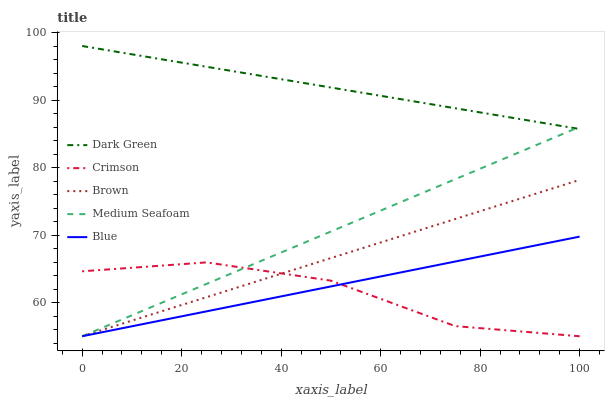Does Crimson have the minimum area under the curve?
Answer yes or no. Yes. Does Dark Green have the maximum area under the curve?
Answer yes or no. Yes. Does Brown have the minimum area under the curve?
Answer yes or no. No. Does Brown have the maximum area under the curve?
Answer yes or no. No. Is Brown the smoothest?
Answer yes or no. Yes. Is Crimson the roughest?
Answer yes or no. Yes. Is Blue the smoothest?
Answer yes or no. No. Is Blue the roughest?
Answer yes or no. No. Does Crimson have the lowest value?
Answer yes or no. Yes. Does Dark Green have the lowest value?
Answer yes or no. No. Does Dark Green have the highest value?
Answer yes or no. Yes. Does Brown have the highest value?
Answer yes or no. No. Is Crimson less than Dark Green?
Answer yes or no. Yes. Is Dark Green greater than Brown?
Answer yes or no. Yes. Does Crimson intersect Blue?
Answer yes or no. Yes. Is Crimson less than Blue?
Answer yes or no. No. Is Crimson greater than Blue?
Answer yes or no. No. Does Crimson intersect Dark Green?
Answer yes or no. No. 